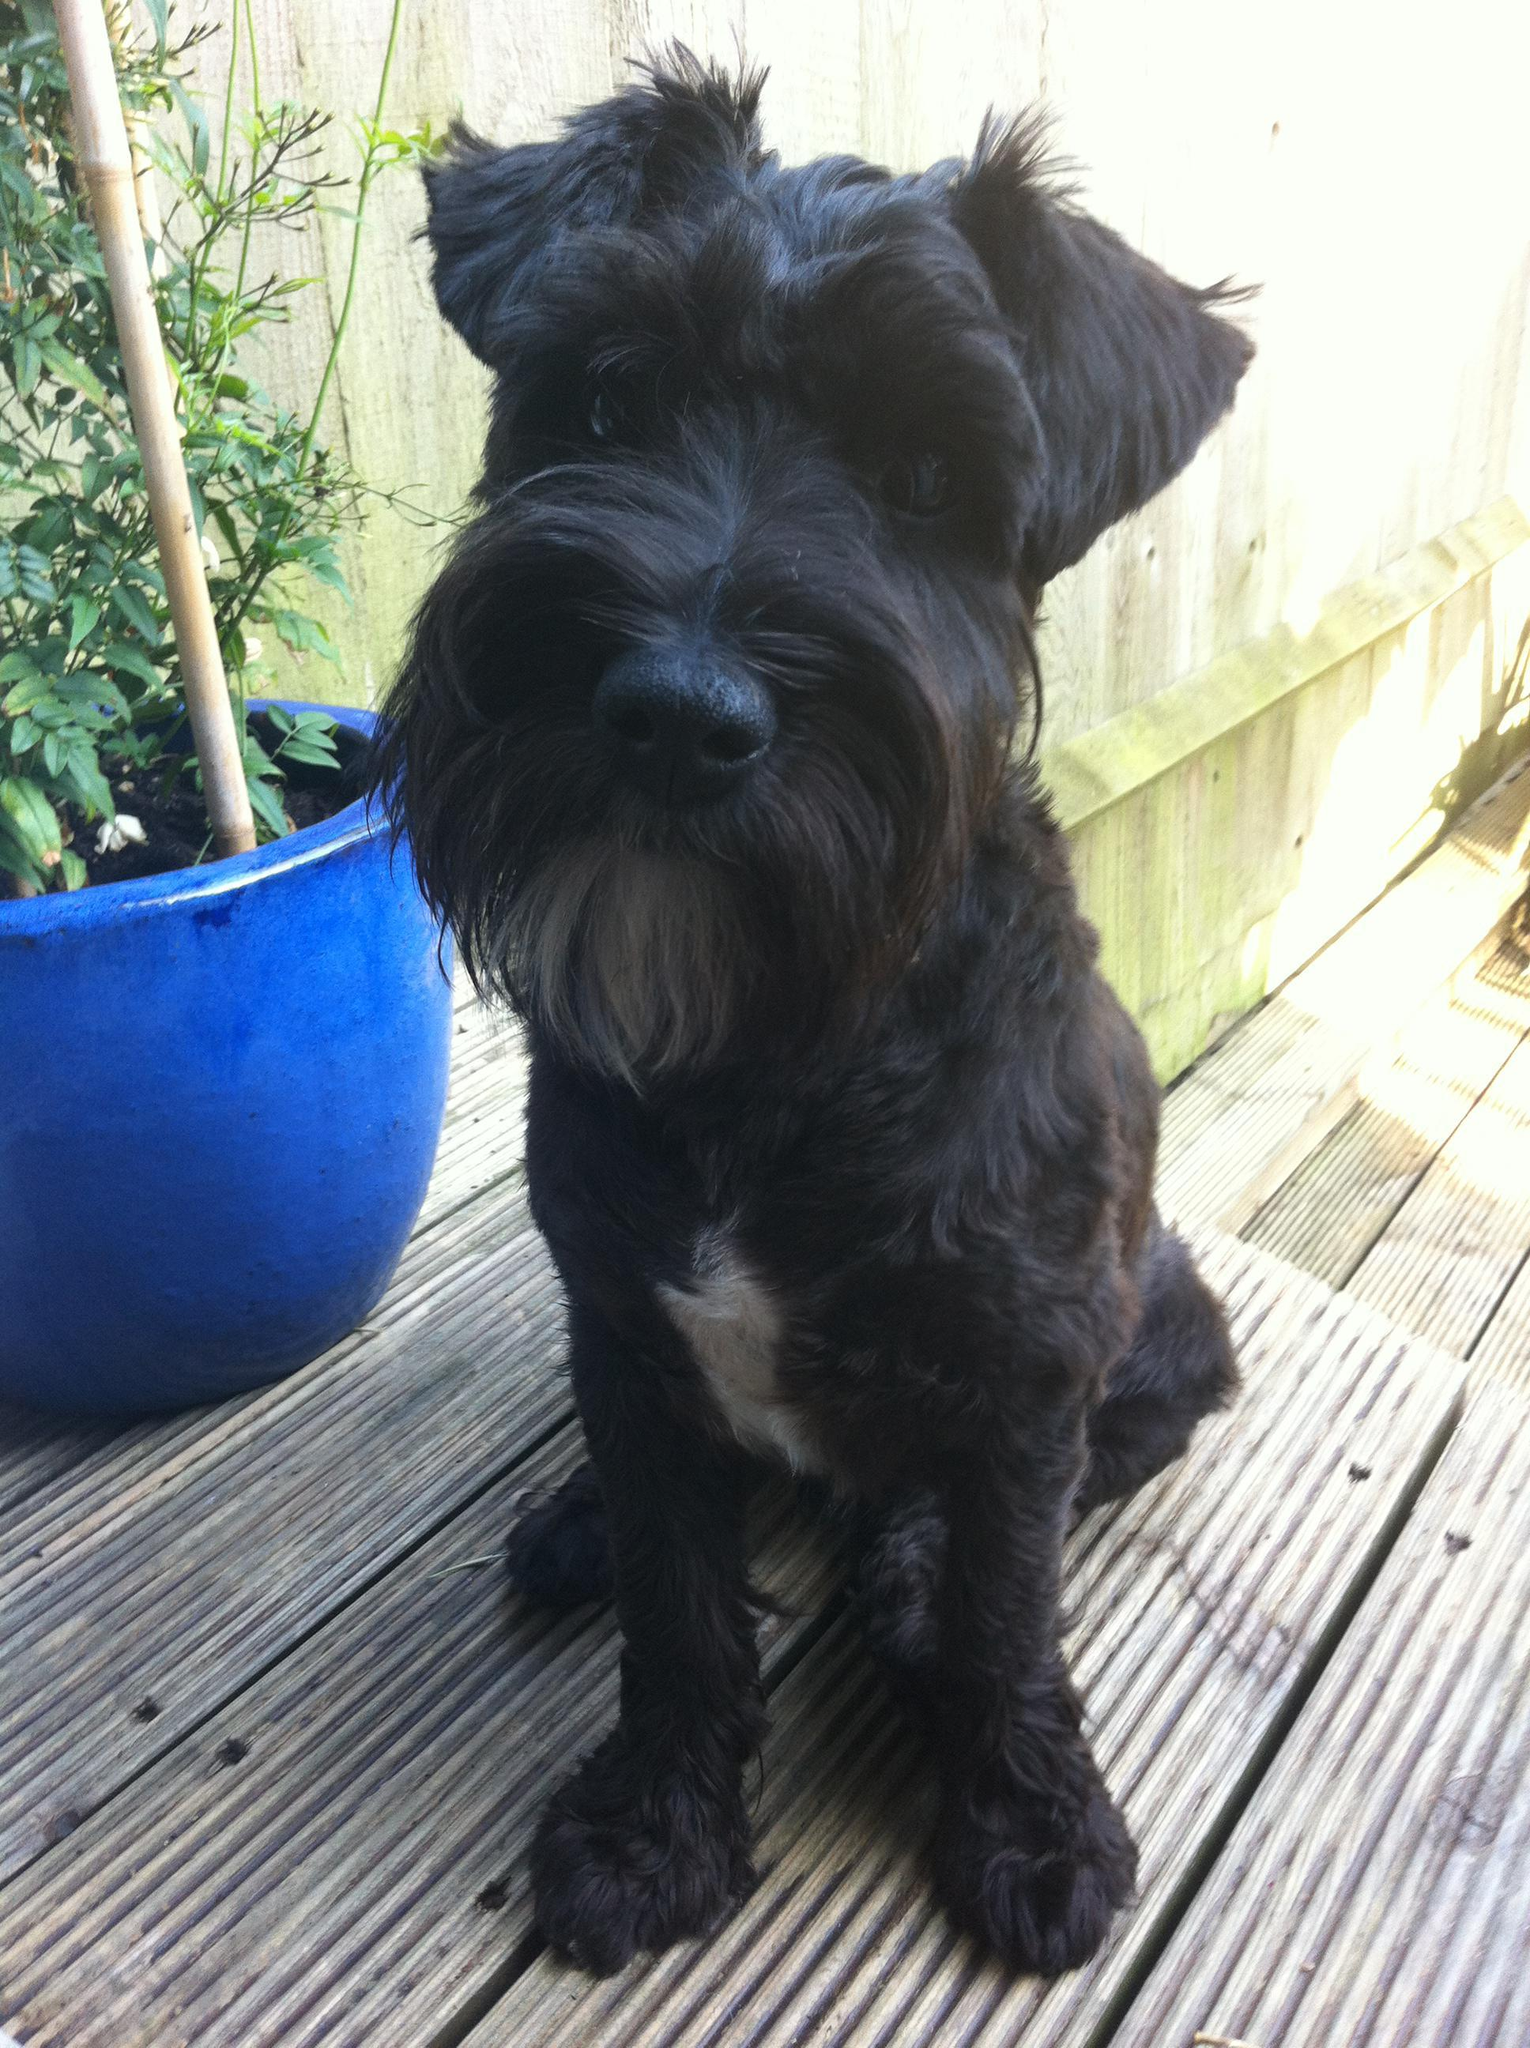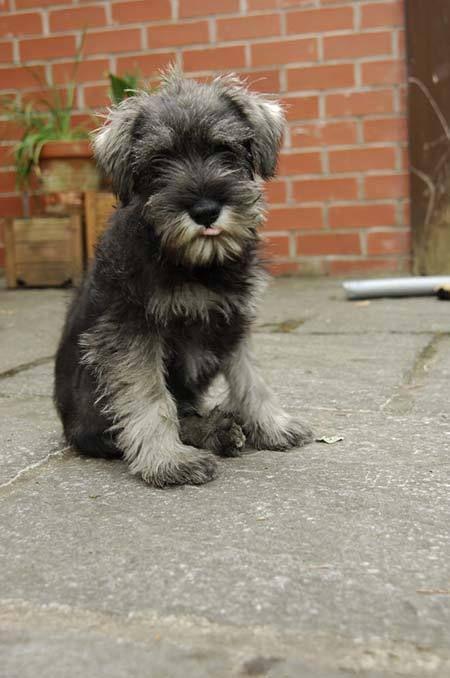The first image is the image on the left, the second image is the image on the right. Considering the images on both sides, is "There are at most two dogs." valid? Answer yes or no. Yes. The first image is the image on the left, the second image is the image on the right. Analyze the images presented: Is the assertion "One of the images has two dogs that are sitting." valid? Answer yes or no. No. 